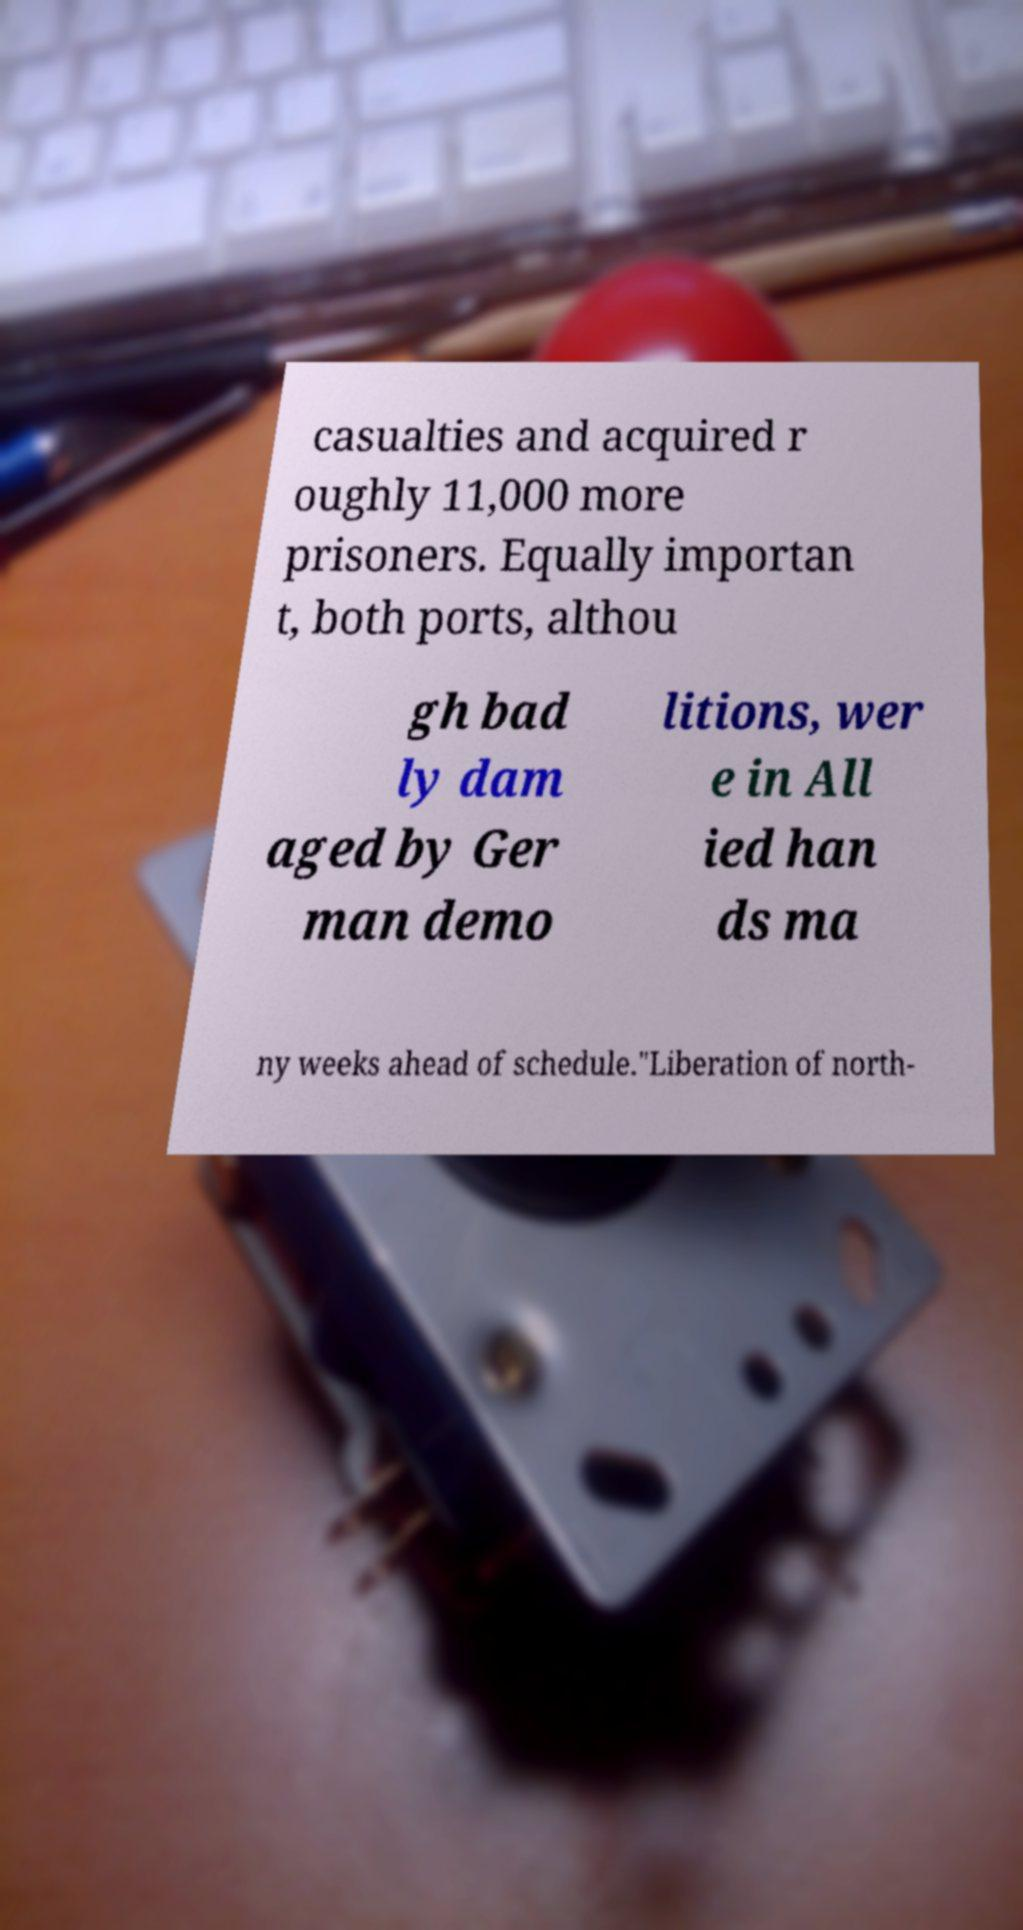There's text embedded in this image that I need extracted. Can you transcribe it verbatim? casualties and acquired r oughly 11,000 more prisoners. Equally importan t, both ports, althou gh bad ly dam aged by Ger man demo litions, wer e in All ied han ds ma ny weeks ahead of schedule."Liberation of north- 